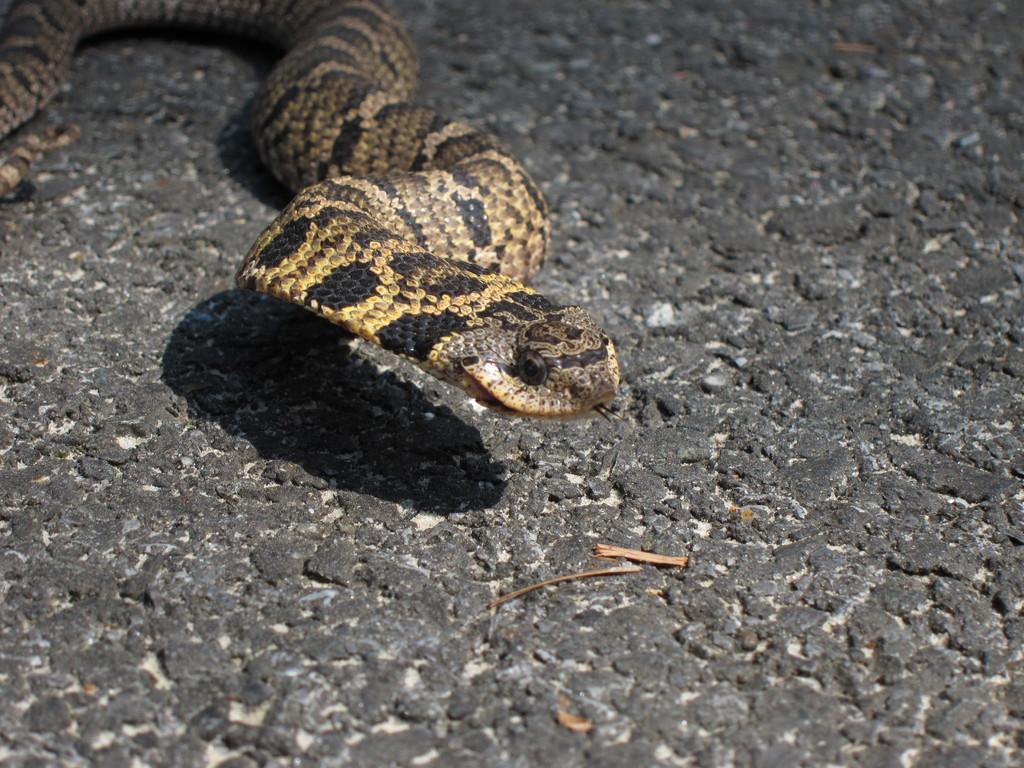Can you describe this image briefly? In the picture we can see a rock surface on it, we can see a snake, which is cream in color with some black color dots on it. 